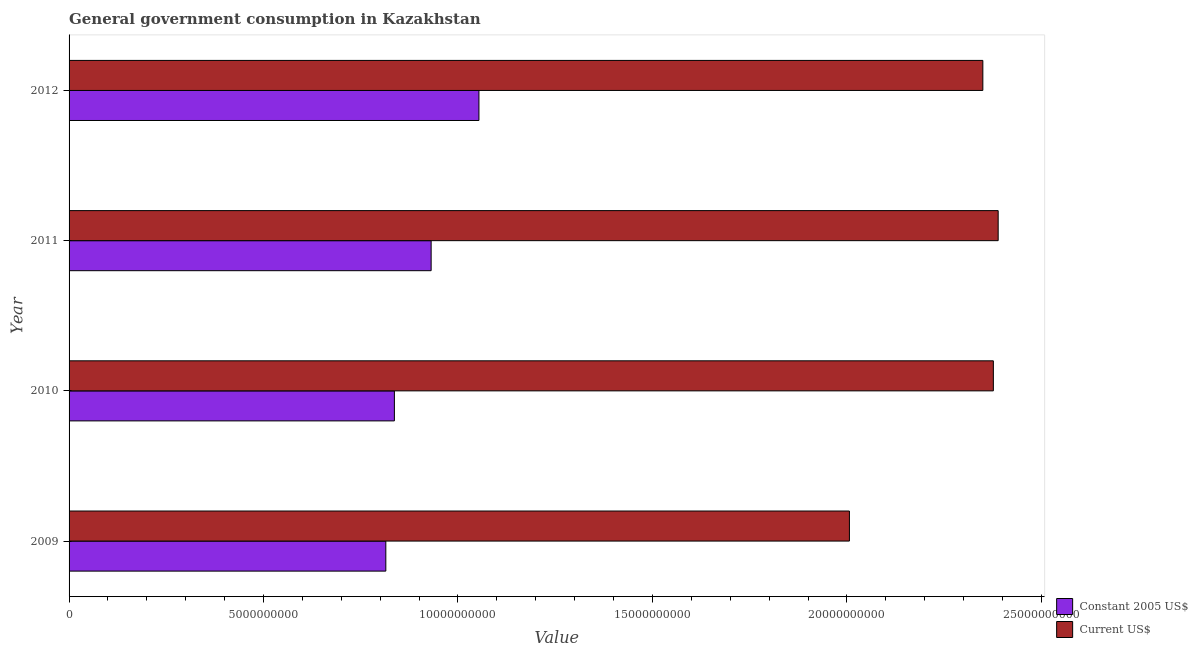How many groups of bars are there?
Your response must be concise. 4. Are the number of bars on each tick of the Y-axis equal?
Make the answer very short. Yes. What is the value consumed in constant 2005 us$ in 2010?
Your answer should be compact. 8.36e+09. Across all years, what is the maximum value consumed in constant 2005 us$?
Ensure brevity in your answer.  1.05e+1. Across all years, what is the minimum value consumed in current us$?
Give a very brief answer. 2.01e+1. In which year was the value consumed in current us$ maximum?
Offer a terse response. 2011. What is the total value consumed in current us$ in the graph?
Make the answer very short. 9.12e+1. What is the difference between the value consumed in constant 2005 us$ in 2010 and that in 2012?
Ensure brevity in your answer.  -2.17e+09. What is the difference between the value consumed in constant 2005 us$ in 2009 and the value consumed in current us$ in 2010?
Offer a very short reply. -1.56e+1. What is the average value consumed in constant 2005 us$ per year?
Your answer should be very brief. 9.09e+09. In the year 2011, what is the difference between the value consumed in constant 2005 us$ and value consumed in current us$?
Offer a terse response. -1.46e+1. In how many years, is the value consumed in current us$ greater than 16000000000 ?
Make the answer very short. 4. What is the ratio of the value consumed in constant 2005 us$ in 2009 to that in 2010?
Offer a very short reply. 0.97. Is the value consumed in current us$ in 2010 less than that in 2011?
Keep it short and to the point. Yes. Is the difference between the value consumed in constant 2005 us$ in 2011 and 2012 greater than the difference between the value consumed in current us$ in 2011 and 2012?
Ensure brevity in your answer.  No. What is the difference between the highest and the second highest value consumed in constant 2005 us$?
Your response must be concise. 1.23e+09. What is the difference between the highest and the lowest value consumed in constant 2005 us$?
Your response must be concise. 2.39e+09. Is the sum of the value consumed in constant 2005 us$ in 2010 and 2012 greater than the maximum value consumed in current us$ across all years?
Your answer should be very brief. No. What does the 1st bar from the top in 2010 represents?
Your answer should be very brief. Current US$. What does the 2nd bar from the bottom in 2011 represents?
Provide a short and direct response. Current US$. How many bars are there?
Your response must be concise. 8. Are all the bars in the graph horizontal?
Ensure brevity in your answer.  Yes. What is the difference between two consecutive major ticks on the X-axis?
Provide a succinct answer. 5.00e+09. Are the values on the major ticks of X-axis written in scientific E-notation?
Keep it short and to the point. No. Does the graph contain any zero values?
Provide a short and direct response. No. Does the graph contain grids?
Your answer should be compact. No. How many legend labels are there?
Ensure brevity in your answer.  2. What is the title of the graph?
Ensure brevity in your answer.  General government consumption in Kazakhstan. What is the label or title of the X-axis?
Provide a short and direct response. Value. What is the Value of Constant 2005 US$ in 2009?
Keep it short and to the point. 8.14e+09. What is the Value in Current US$ in 2009?
Give a very brief answer. 2.01e+1. What is the Value of Constant 2005 US$ in 2010?
Provide a short and direct response. 8.36e+09. What is the Value in Current US$ in 2010?
Give a very brief answer. 2.38e+1. What is the Value in Constant 2005 US$ in 2011?
Offer a terse response. 9.31e+09. What is the Value in Current US$ in 2011?
Ensure brevity in your answer.  2.39e+1. What is the Value in Constant 2005 US$ in 2012?
Provide a short and direct response. 1.05e+1. What is the Value in Current US$ in 2012?
Make the answer very short. 2.35e+1. Across all years, what is the maximum Value in Constant 2005 US$?
Offer a very short reply. 1.05e+1. Across all years, what is the maximum Value in Current US$?
Your answer should be compact. 2.39e+1. Across all years, what is the minimum Value of Constant 2005 US$?
Offer a very short reply. 8.14e+09. Across all years, what is the minimum Value in Current US$?
Offer a terse response. 2.01e+1. What is the total Value in Constant 2005 US$ in the graph?
Your answer should be compact. 3.64e+1. What is the total Value of Current US$ in the graph?
Keep it short and to the point. 9.12e+1. What is the difference between the Value in Constant 2005 US$ in 2009 and that in 2010?
Your response must be concise. -2.20e+08. What is the difference between the Value of Current US$ in 2009 and that in 2010?
Provide a short and direct response. -3.70e+09. What is the difference between the Value in Constant 2005 US$ in 2009 and that in 2011?
Make the answer very short. -1.17e+09. What is the difference between the Value of Current US$ in 2009 and that in 2011?
Keep it short and to the point. -3.82e+09. What is the difference between the Value of Constant 2005 US$ in 2009 and that in 2012?
Ensure brevity in your answer.  -2.39e+09. What is the difference between the Value of Current US$ in 2009 and that in 2012?
Ensure brevity in your answer.  -3.43e+09. What is the difference between the Value of Constant 2005 US$ in 2010 and that in 2011?
Make the answer very short. -9.45e+08. What is the difference between the Value of Current US$ in 2010 and that in 2011?
Offer a terse response. -1.24e+08. What is the difference between the Value of Constant 2005 US$ in 2010 and that in 2012?
Your answer should be compact. -2.17e+09. What is the difference between the Value in Current US$ in 2010 and that in 2012?
Keep it short and to the point. 2.70e+08. What is the difference between the Value of Constant 2005 US$ in 2011 and that in 2012?
Provide a short and direct response. -1.23e+09. What is the difference between the Value of Current US$ in 2011 and that in 2012?
Give a very brief answer. 3.94e+08. What is the difference between the Value of Constant 2005 US$ in 2009 and the Value of Current US$ in 2010?
Ensure brevity in your answer.  -1.56e+1. What is the difference between the Value of Constant 2005 US$ in 2009 and the Value of Current US$ in 2011?
Ensure brevity in your answer.  -1.57e+1. What is the difference between the Value in Constant 2005 US$ in 2009 and the Value in Current US$ in 2012?
Ensure brevity in your answer.  -1.54e+1. What is the difference between the Value in Constant 2005 US$ in 2010 and the Value in Current US$ in 2011?
Your answer should be compact. -1.55e+1. What is the difference between the Value in Constant 2005 US$ in 2010 and the Value in Current US$ in 2012?
Make the answer very short. -1.51e+1. What is the difference between the Value in Constant 2005 US$ in 2011 and the Value in Current US$ in 2012?
Provide a short and direct response. -1.42e+1. What is the average Value in Constant 2005 US$ per year?
Ensure brevity in your answer.  9.09e+09. What is the average Value in Current US$ per year?
Ensure brevity in your answer.  2.28e+1. In the year 2009, what is the difference between the Value in Constant 2005 US$ and Value in Current US$?
Your answer should be very brief. -1.19e+1. In the year 2010, what is the difference between the Value in Constant 2005 US$ and Value in Current US$?
Your response must be concise. -1.54e+1. In the year 2011, what is the difference between the Value in Constant 2005 US$ and Value in Current US$?
Your answer should be compact. -1.46e+1. In the year 2012, what is the difference between the Value in Constant 2005 US$ and Value in Current US$?
Give a very brief answer. -1.30e+1. What is the ratio of the Value in Constant 2005 US$ in 2009 to that in 2010?
Your response must be concise. 0.97. What is the ratio of the Value of Current US$ in 2009 to that in 2010?
Your response must be concise. 0.84. What is the ratio of the Value in Constant 2005 US$ in 2009 to that in 2011?
Your answer should be compact. 0.87. What is the ratio of the Value in Current US$ in 2009 to that in 2011?
Keep it short and to the point. 0.84. What is the ratio of the Value in Constant 2005 US$ in 2009 to that in 2012?
Offer a terse response. 0.77. What is the ratio of the Value of Current US$ in 2009 to that in 2012?
Offer a very short reply. 0.85. What is the ratio of the Value of Constant 2005 US$ in 2010 to that in 2011?
Offer a very short reply. 0.9. What is the ratio of the Value in Current US$ in 2010 to that in 2011?
Offer a terse response. 0.99. What is the ratio of the Value in Constant 2005 US$ in 2010 to that in 2012?
Give a very brief answer. 0.79. What is the ratio of the Value of Current US$ in 2010 to that in 2012?
Ensure brevity in your answer.  1.01. What is the ratio of the Value of Constant 2005 US$ in 2011 to that in 2012?
Make the answer very short. 0.88. What is the ratio of the Value in Current US$ in 2011 to that in 2012?
Your response must be concise. 1.02. What is the difference between the highest and the second highest Value of Constant 2005 US$?
Your answer should be very brief. 1.23e+09. What is the difference between the highest and the second highest Value of Current US$?
Ensure brevity in your answer.  1.24e+08. What is the difference between the highest and the lowest Value in Constant 2005 US$?
Give a very brief answer. 2.39e+09. What is the difference between the highest and the lowest Value of Current US$?
Make the answer very short. 3.82e+09. 